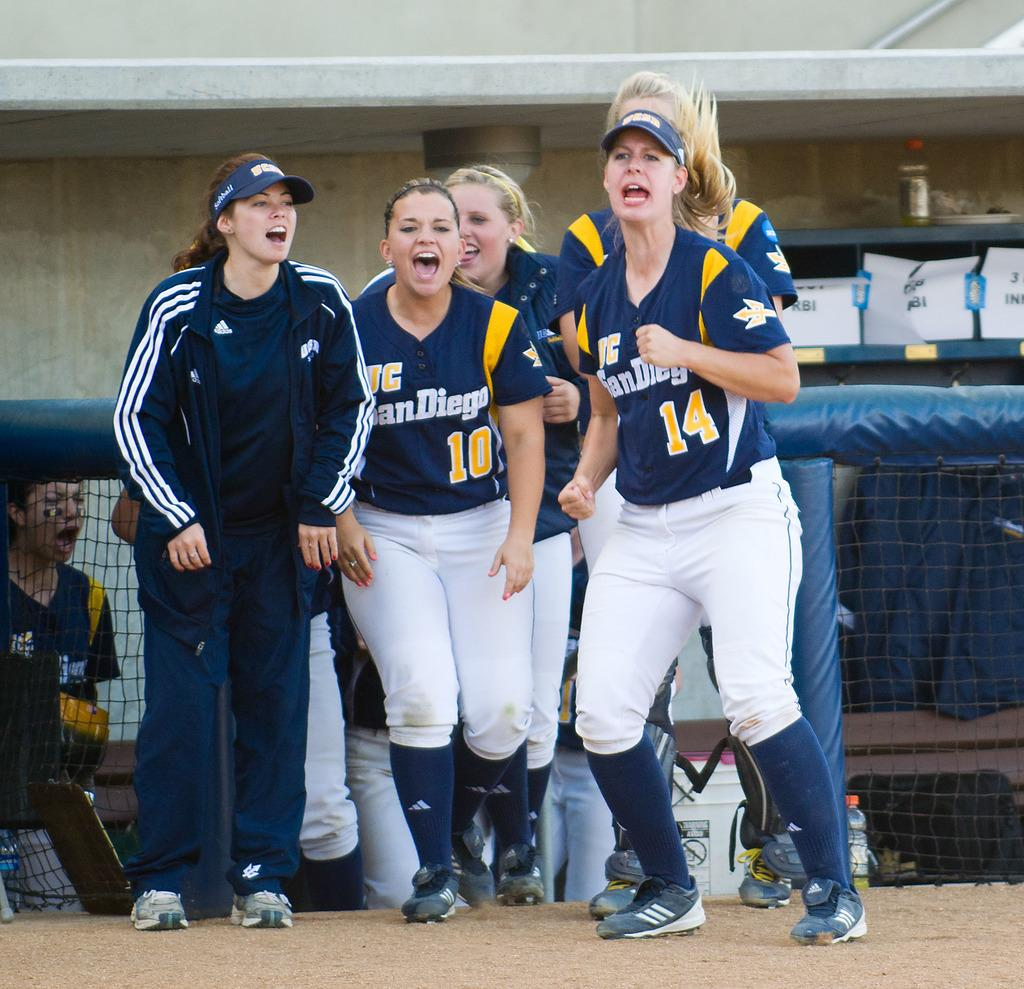<image>
Provide a brief description of the given image. The women play for the San Diego softball team. 